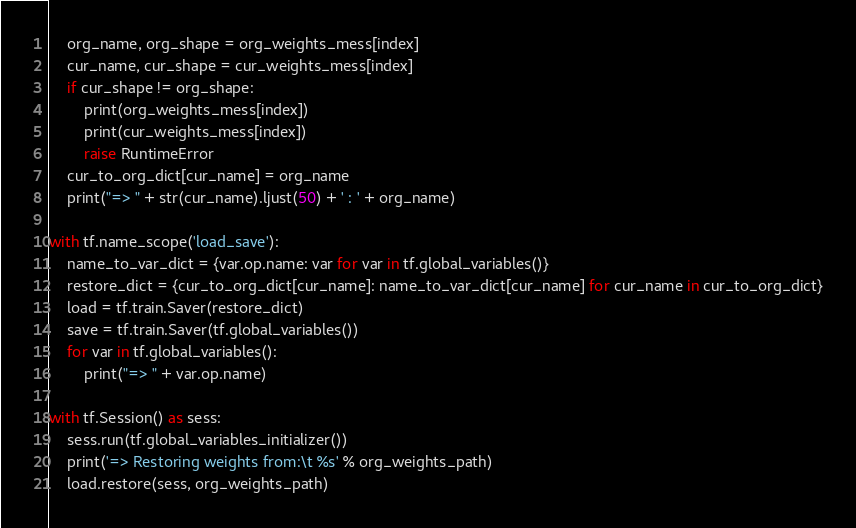Convert code to text. <code><loc_0><loc_0><loc_500><loc_500><_Python_>    org_name, org_shape = org_weights_mess[index]
    cur_name, cur_shape = cur_weights_mess[index]
    if cur_shape != org_shape:
        print(org_weights_mess[index])
        print(cur_weights_mess[index])
        raise RuntimeError
    cur_to_org_dict[cur_name] = org_name
    print("=> " + str(cur_name).ljust(50) + ' : ' + org_name)

with tf.name_scope('load_save'):
    name_to_var_dict = {var.op.name: var for var in tf.global_variables()}
    restore_dict = {cur_to_org_dict[cur_name]: name_to_var_dict[cur_name] for cur_name in cur_to_org_dict}
    load = tf.train.Saver(restore_dict)
    save = tf.train.Saver(tf.global_variables())
    for var in tf.global_variables():
        print("=> " + var.op.name)

with tf.Session() as sess:
    sess.run(tf.global_variables_initializer())
    print('=> Restoring weights from:\t %s' % org_weights_path)
    load.restore(sess, org_weights_path)</code> 